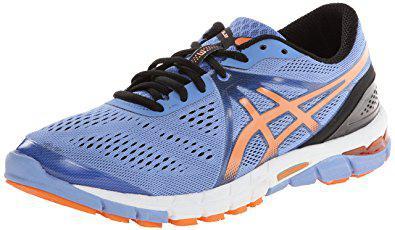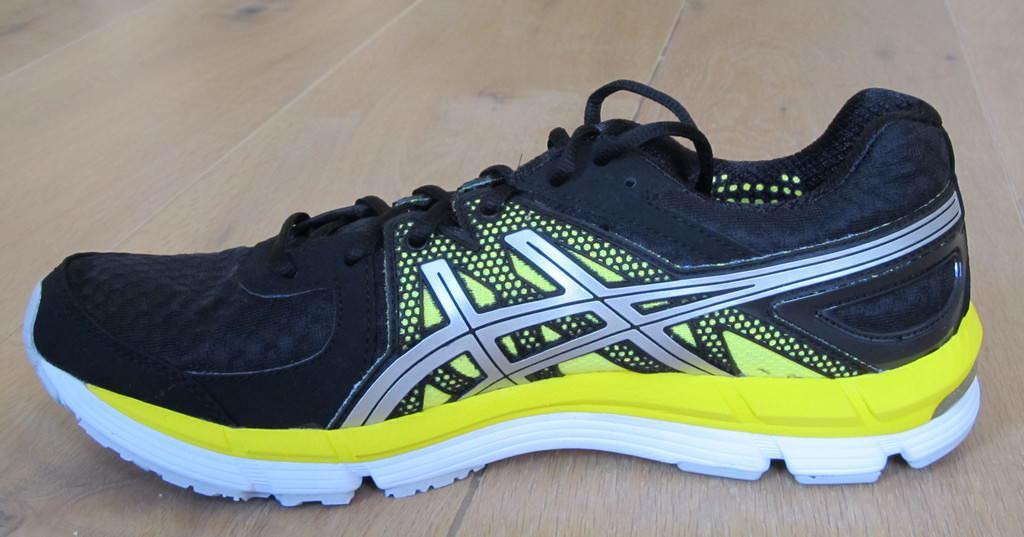The first image is the image on the left, the second image is the image on the right. Examine the images to the left and right. Is the description "the shoe in the image on the left is black" accurate? Answer yes or no. No. 